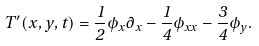Convert formula to latex. <formula><loc_0><loc_0><loc_500><loc_500>T ^ { \prime } ( x , y , t ) = \frac { 1 } { 2 } \phi _ { x } \partial _ { x } - \frac { 1 } { 4 } \phi _ { x x } - \frac { 3 } { 4 } \phi _ { y } .</formula> 